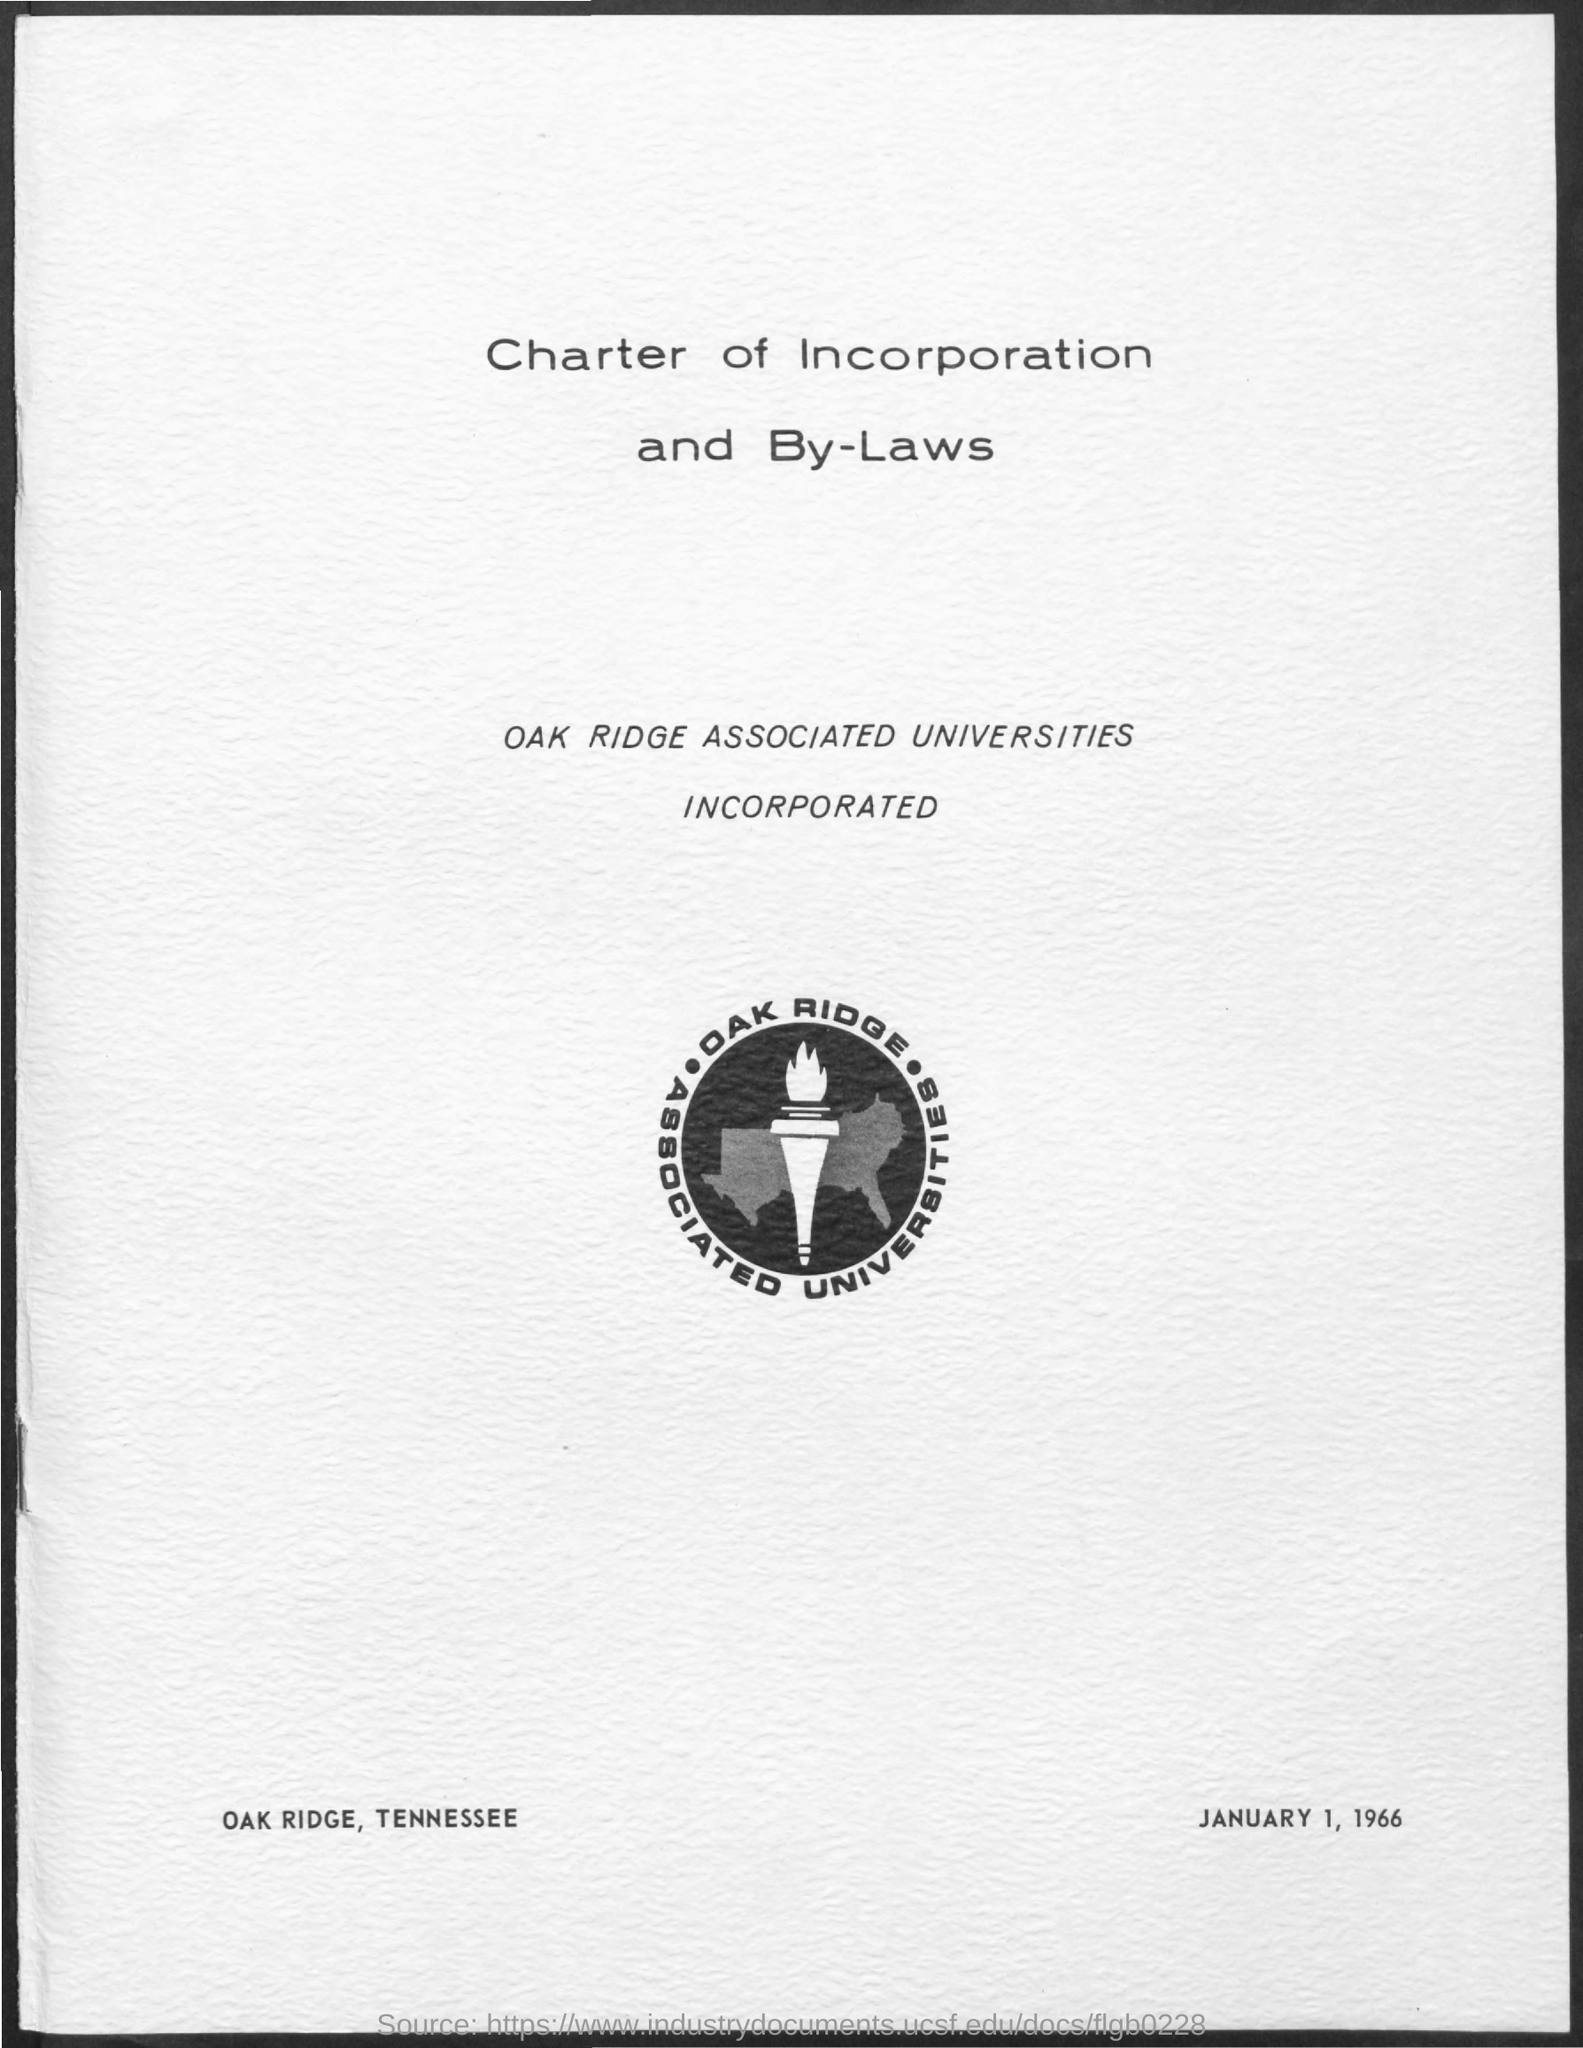Indicate a few pertinent items in this graphic. The document is titled "Charter of Incorporation and By-Laws. Oak Ridge is located in the state of Tennessee. The date mentioned in the document is January 1, 1966. 